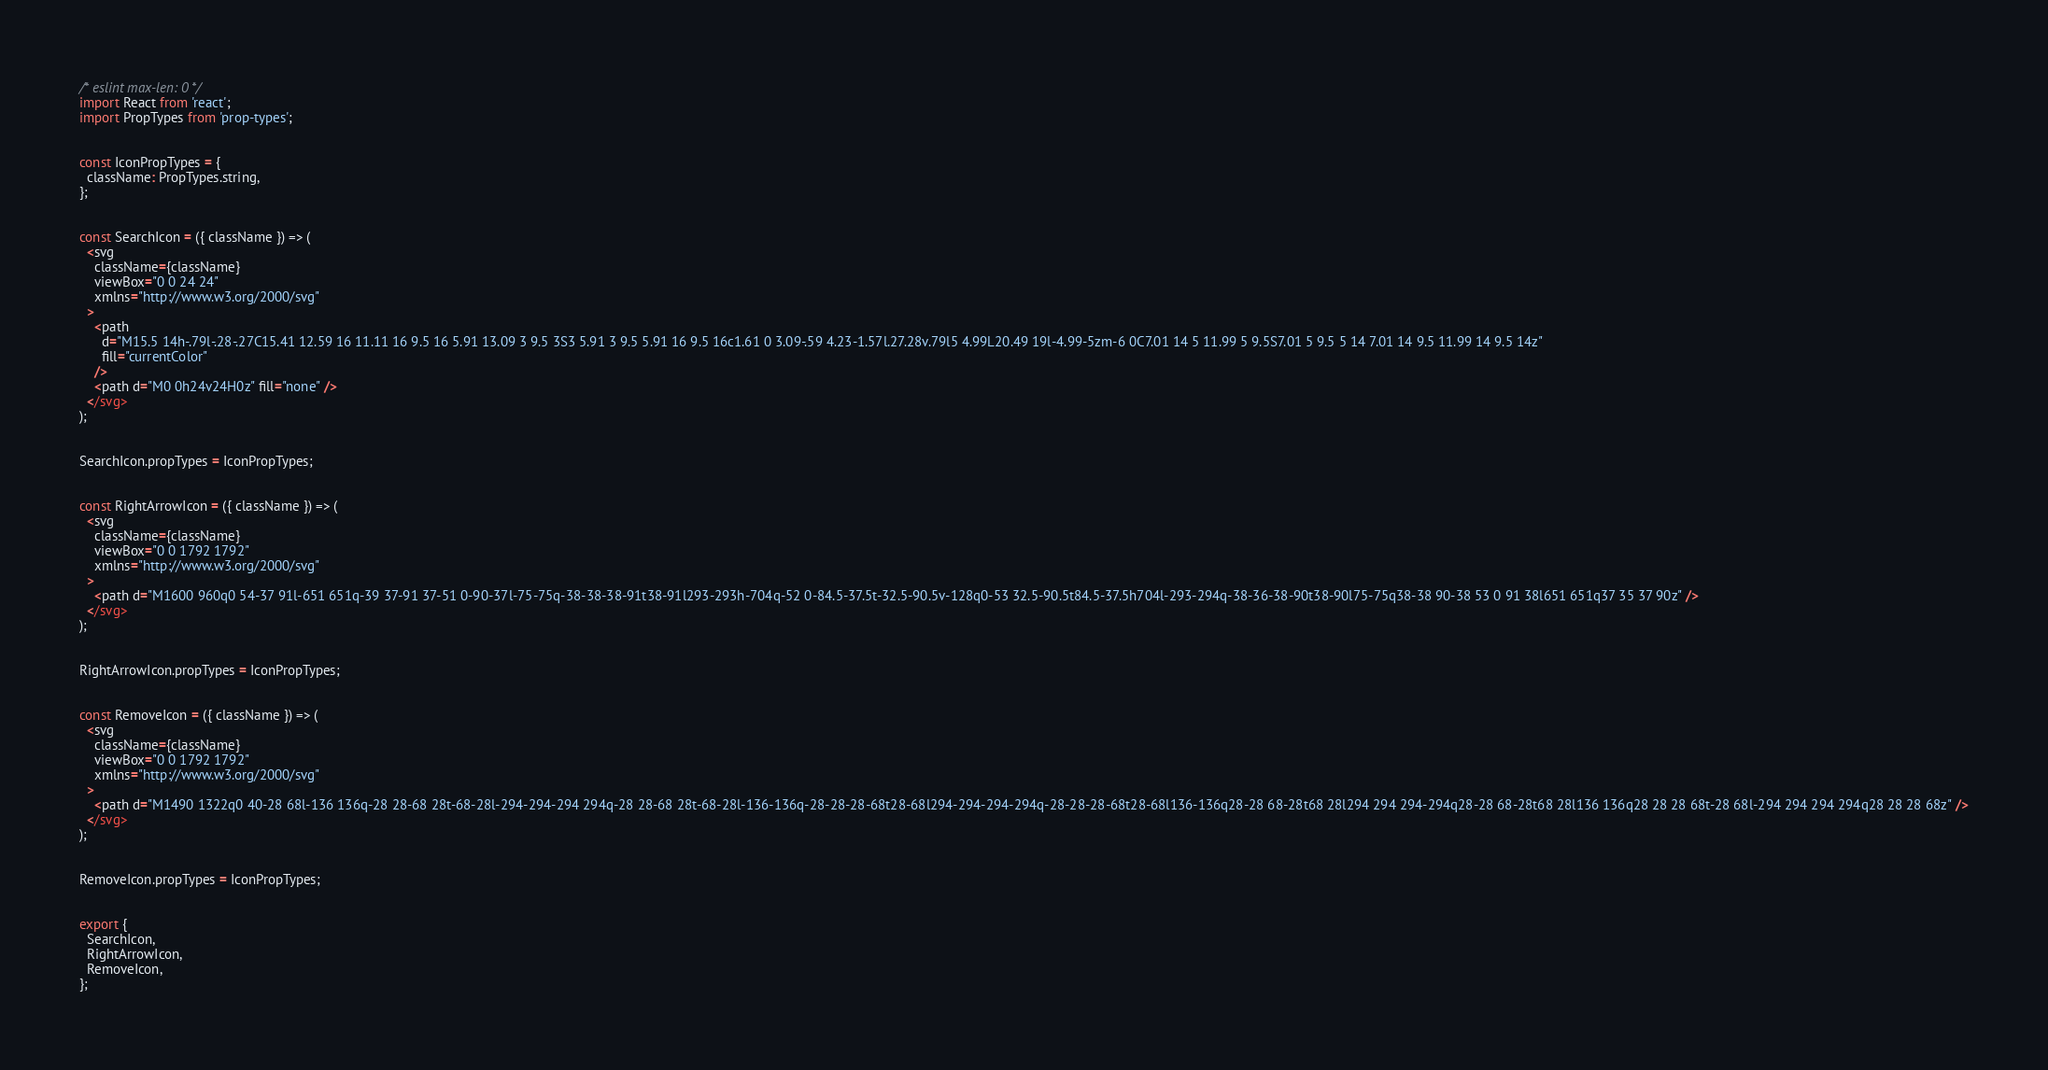Convert code to text. <code><loc_0><loc_0><loc_500><loc_500><_JavaScript_>/* eslint max-len: 0 */
import React from 'react';
import PropTypes from 'prop-types';


const IconPropTypes = {
  className: PropTypes.string,
};


const SearchIcon = ({ className }) => (
  <svg
    className={className}
    viewBox="0 0 24 24"
    xmlns="http://www.w3.org/2000/svg"
  >
    <path
      d="M15.5 14h-.79l-.28-.27C15.41 12.59 16 11.11 16 9.5 16 5.91 13.09 3 9.5 3S3 5.91 3 9.5 5.91 16 9.5 16c1.61 0 3.09-.59 4.23-1.57l.27.28v.79l5 4.99L20.49 19l-4.99-5zm-6 0C7.01 14 5 11.99 5 9.5S7.01 5 9.5 5 14 7.01 14 9.5 11.99 14 9.5 14z"
      fill="currentColor"
    />
    <path d="M0 0h24v24H0z" fill="none" />
  </svg>
);


SearchIcon.propTypes = IconPropTypes;


const RightArrowIcon = ({ className }) => (
  <svg
    className={className}
    viewBox="0 0 1792 1792"
    xmlns="http://www.w3.org/2000/svg"
  >
    <path d="M1600 960q0 54-37 91l-651 651q-39 37-91 37-51 0-90-37l-75-75q-38-38-38-91t38-91l293-293h-704q-52 0-84.5-37.5t-32.5-90.5v-128q0-53 32.5-90.5t84.5-37.5h704l-293-294q-38-36-38-90t38-90l75-75q38-38 90-38 53 0 91 38l651 651q37 35 37 90z" />
  </svg>
);


RightArrowIcon.propTypes = IconPropTypes;


const RemoveIcon = ({ className }) => (
  <svg
    className={className}
    viewBox="0 0 1792 1792"
    xmlns="http://www.w3.org/2000/svg"
  >
    <path d="M1490 1322q0 40-28 68l-136 136q-28 28-68 28t-68-28l-294-294-294 294q-28 28-68 28t-68-28l-136-136q-28-28-28-68t28-68l294-294-294-294q-28-28-28-68t28-68l136-136q28-28 68-28t68 28l294 294 294-294q28-28 68-28t68 28l136 136q28 28 28 68t-28 68l-294 294 294 294q28 28 28 68z" />
  </svg>
);


RemoveIcon.propTypes = IconPropTypes;


export {
  SearchIcon,
  RightArrowIcon,
  RemoveIcon,
};
</code> 